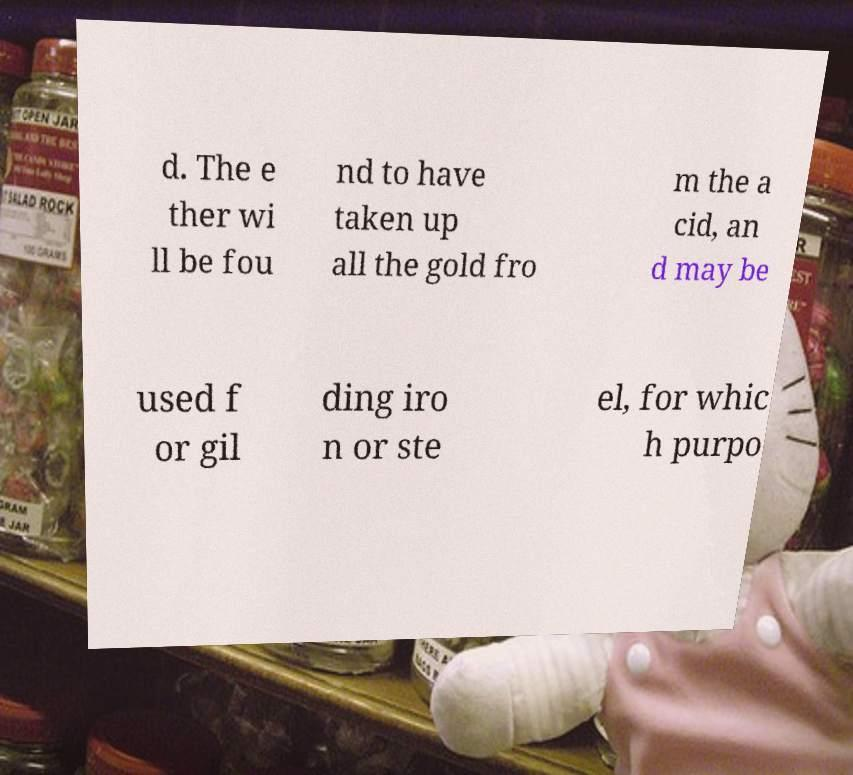Could you assist in decoding the text presented in this image and type it out clearly? d. The e ther wi ll be fou nd to have taken up all the gold fro m the a cid, an d may be used f or gil ding iro n or ste el, for whic h purpo 